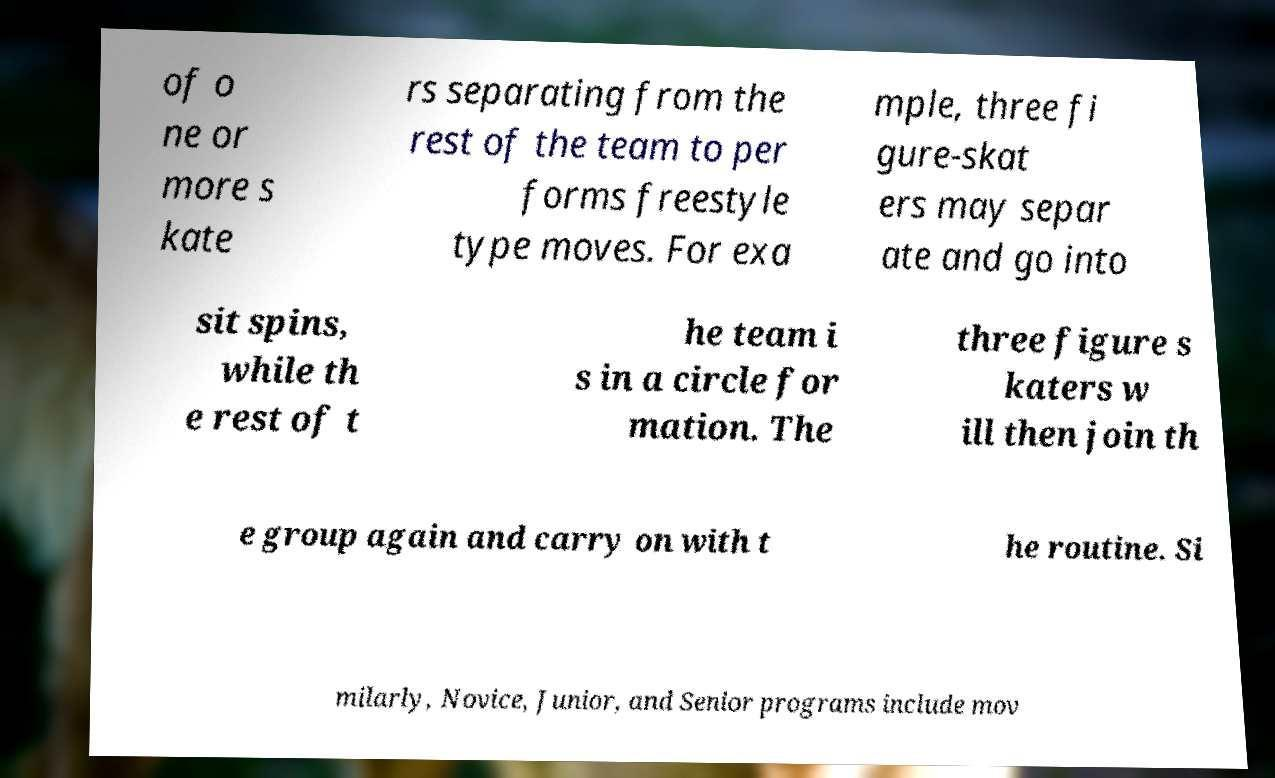Please read and relay the text visible in this image. What does it say? of o ne or more s kate rs separating from the rest of the team to per forms freestyle type moves. For exa mple, three fi gure-skat ers may separ ate and go into sit spins, while th e rest of t he team i s in a circle for mation. The three figure s katers w ill then join th e group again and carry on with t he routine. Si milarly, Novice, Junior, and Senior programs include mov 